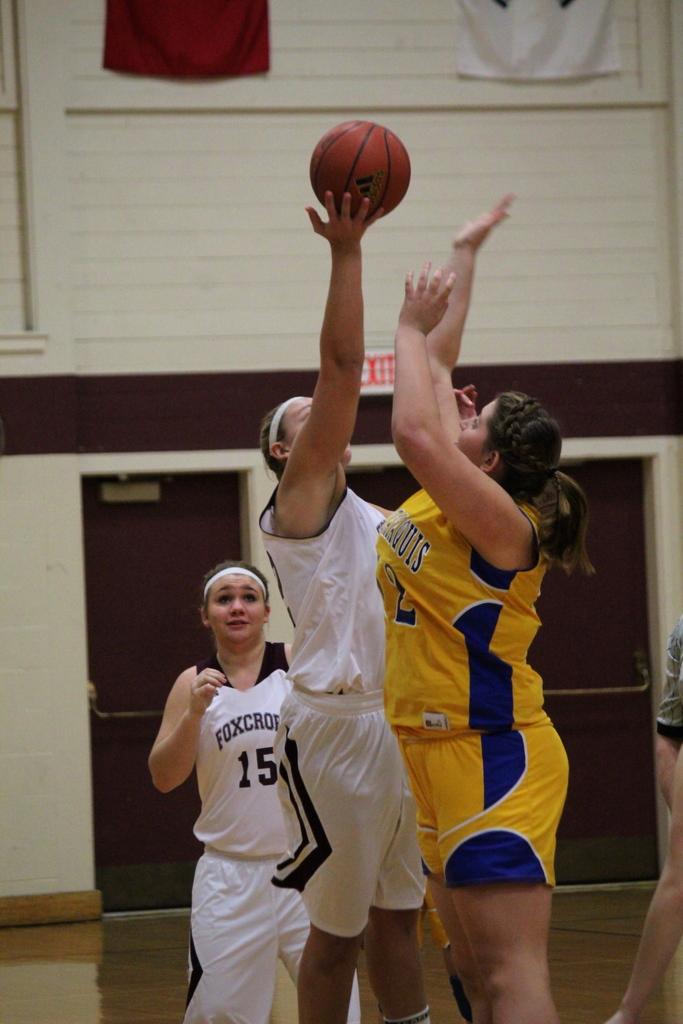What team has the ball?
Keep it short and to the point. Foxcroft. What number is on the white jersey in the back?
Your response must be concise. 15. 